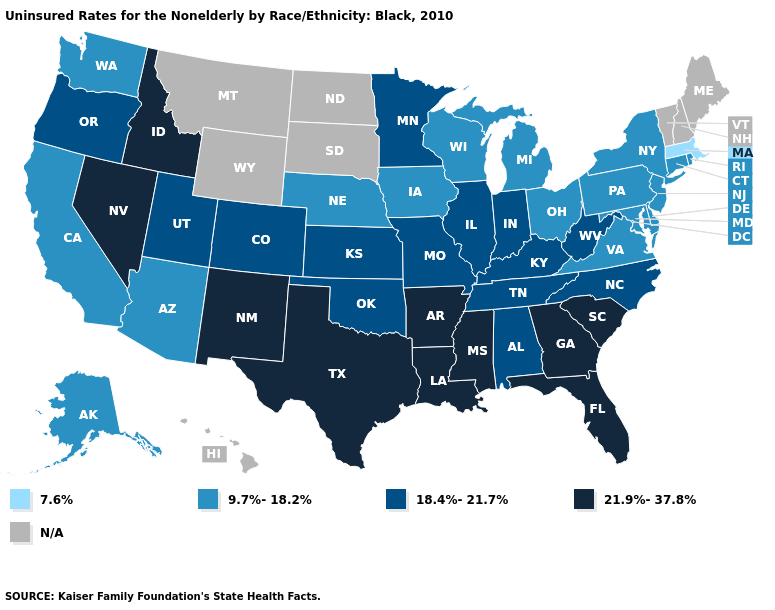Which states have the highest value in the USA?
Write a very short answer. Arkansas, Florida, Georgia, Idaho, Louisiana, Mississippi, Nevada, New Mexico, South Carolina, Texas. What is the value of Maryland?
Short answer required. 9.7%-18.2%. Name the states that have a value in the range 9.7%-18.2%?
Write a very short answer. Alaska, Arizona, California, Connecticut, Delaware, Iowa, Maryland, Michigan, Nebraska, New Jersey, New York, Ohio, Pennsylvania, Rhode Island, Virginia, Washington, Wisconsin. Which states have the highest value in the USA?
Give a very brief answer. Arkansas, Florida, Georgia, Idaho, Louisiana, Mississippi, Nevada, New Mexico, South Carolina, Texas. What is the value of South Dakota?
Be succinct. N/A. Name the states that have a value in the range 21.9%-37.8%?
Quick response, please. Arkansas, Florida, Georgia, Idaho, Louisiana, Mississippi, Nevada, New Mexico, South Carolina, Texas. Among the states that border Pennsylvania , which have the highest value?
Quick response, please. West Virginia. What is the highest value in the USA?
Give a very brief answer. 21.9%-37.8%. How many symbols are there in the legend?
Concise answer only. 5. What is the value of Connecticut?
Concise answer only. 9.7%-18.2%. What is the lowest value in the USA?
Keep it brief. 7.6%. Is the legend a continuous bar?
Concise answer only. No. What is the value of Kentucky?
Answer briefly. 18.4%-21.7%. Name the states that have a value in the range 21.9%-37.8%?
Give a very brief answer. Arkansas, Florida, Georgia, Idaho, Louisiana, Mississippi, Nevada, New Mexico, South Carolina, Texas. Does the map have missing data?
Short answer required. Yes. 